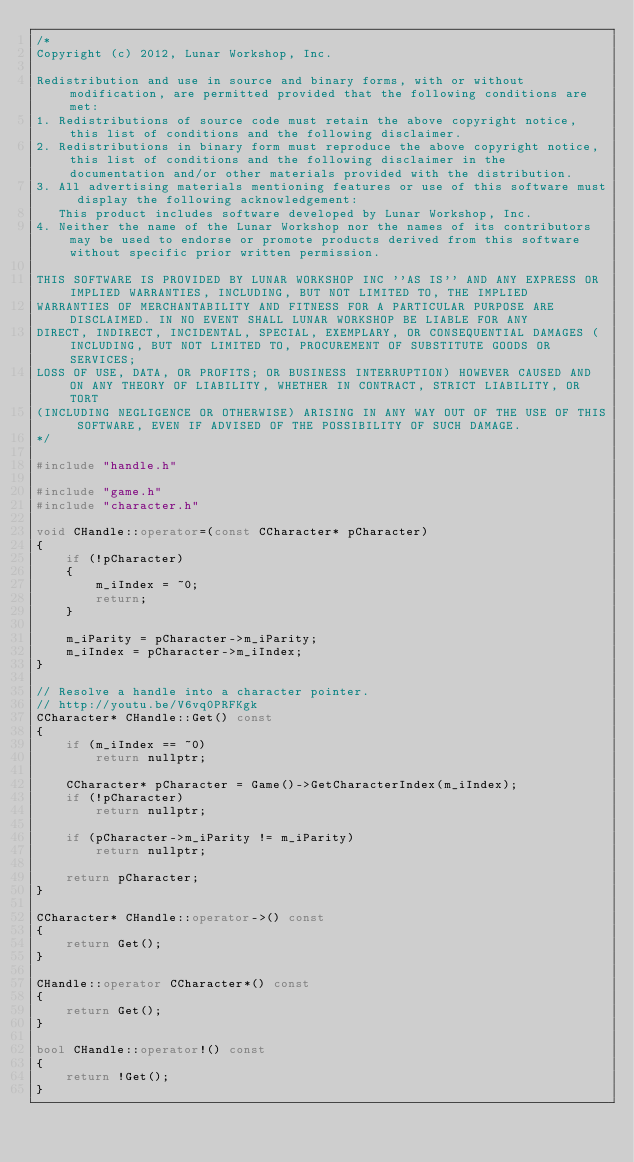Convert code to text. <code><loc_0><loc_0><loc_500><loc_500><_C++_>/*
Copyright (c) 2012, Lunar Workshop, Inc.

Redistribution and use in source and binary forms, with or without modification, are permitted provided that the following conditions are met:
1. Redistributions of source code must retain the above copyright notice, this list of conditions and the following disclaimer.
2. Redistributions in binary form must reproduce the above copyright notice, this list of conditions and the following disclaimer in the documentation and/or other materials provided with the distribution.
3. All advertising materials mentioning features or use of this software must display the following acknowledgement:
   This product includes software developed by Lunar Workshop, Inc.
4. Neither the name of the Lunar Workshop nor the names of its contributors may be used to endorse or promote products derived from this software without specific prior written permission.

THIS SOFTWARE IS PROVIDED BY LUNAR WORKSHOP INC ''AS IS'' AND ANY EXPRESS OR IMPLIED WARRANTIES, INCLUDING, BUT NOT LIMITED TO, THE IMPLIED
WARRANTIES OF MERCHANTABILITY AND FITNESS FOR A PARTICULAR PURPOSE ARE DISCLAIMED. IN NO EVENT SHALL LUNAR WORKSHOP BE LIABLE FOR ANY
DIRECT, INDIRECT, INCIDENTAL, SPECIAL, EXEMPLARY, OR CONSEQUENTIAL DAMAGES (INCLUDING, BUT NOT LIMITED TO, PROCUREMENT OF SUBSTITUTE GOODS OR SERVICES;
LOSS OF USE, DATA, OR PROFITS; OR BUSINESS INTERRUPTION) HOWEVER CAUSED AND ON ANY THEORY OF LIABILITY, WHETHER IN CONTRACT, STRICT LIABILITY, OR TORT
(INCLUDING NEGLIGENCE OR OTHERWISE) ARISING IN ANY WAY OUT OF THE USE OF THIS SOFTWARE, EVEN IF ADVISED OF THE POSSIBILITY OF SUCH DAMAGE.
*/

#include "handle.h"

#include "game.h"
#include "character.h"

void CHandle::operator=(const CCharacter* pCharacter)
{
	if (!pCharacter)
	{
		m_iIndex = ~0;
		return;
	}

	m_iParity = pCharacter->m_iParity;
	m_iIndex = pCharacter->m_iIndex;
}

// Resolve a handle into a character pointer.
// http://youtu.be/V6vq0PRFKgk
CCharacter* CHandle::Get() const
{
	if (m_iIndex == ~0)
		return nullptr;

	CCharacter* pCharacter = Game()->GetCharacterIndex(m_iIndex);
	if (!pCharacter)
		return nullptr;

	if (pCharacter->m_iParity != m_iParity)
		return nullptr;

	return pCharacter;
}

CCharacter* CHandle::operator->() const
{
	return Get();
}

CHandle::operator CCharacter*() const
{
	return Get();
}

bool CHandle::operator!() const
{
	return !Get();
}
</code> 